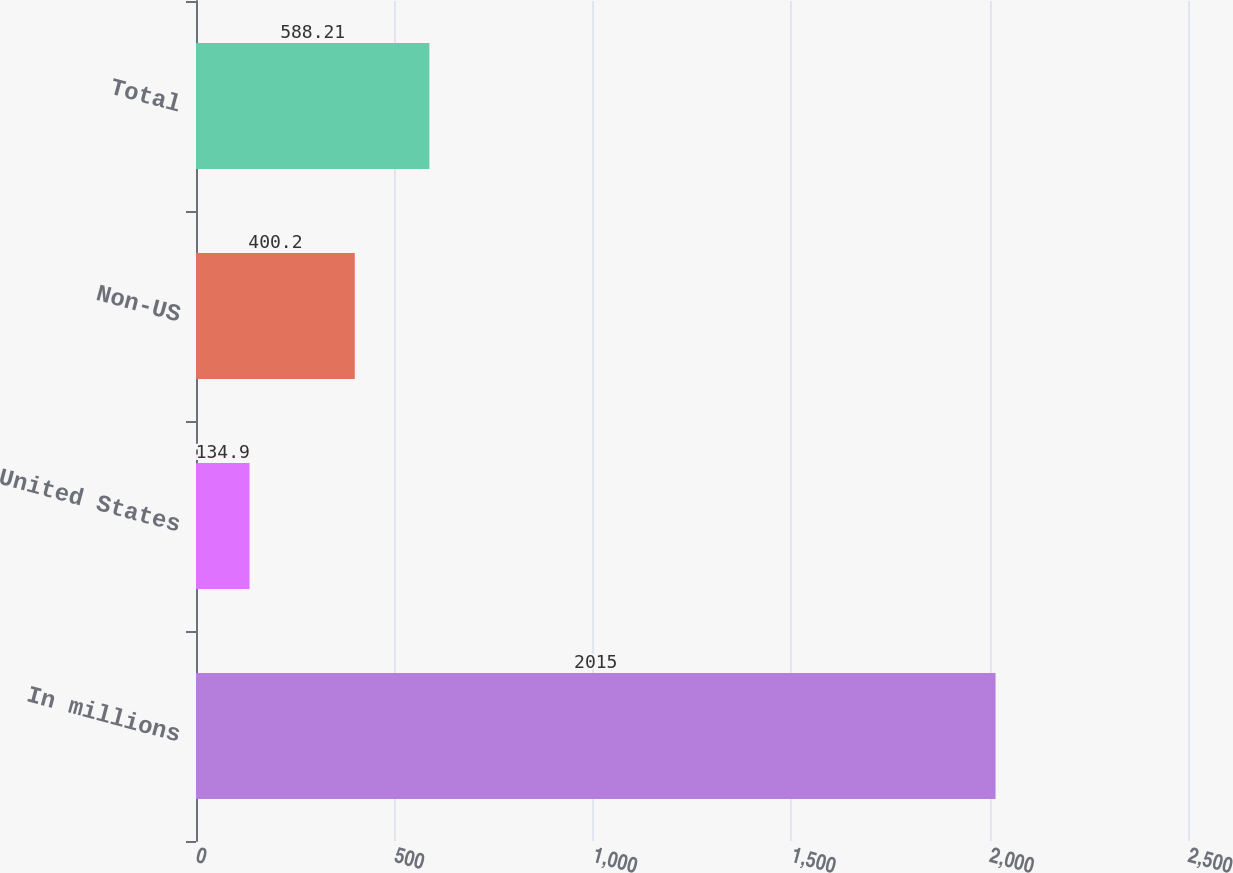<chart> <loc_0><loc_0><loc_500><loc_500><bar_chart><fcel>In millions<fcel>United States<fcel>Non-US<fcel>Total<nl><fcel>2015<fcel>134.9<fcel>400.2<fcel>588.21<nl></chart> 